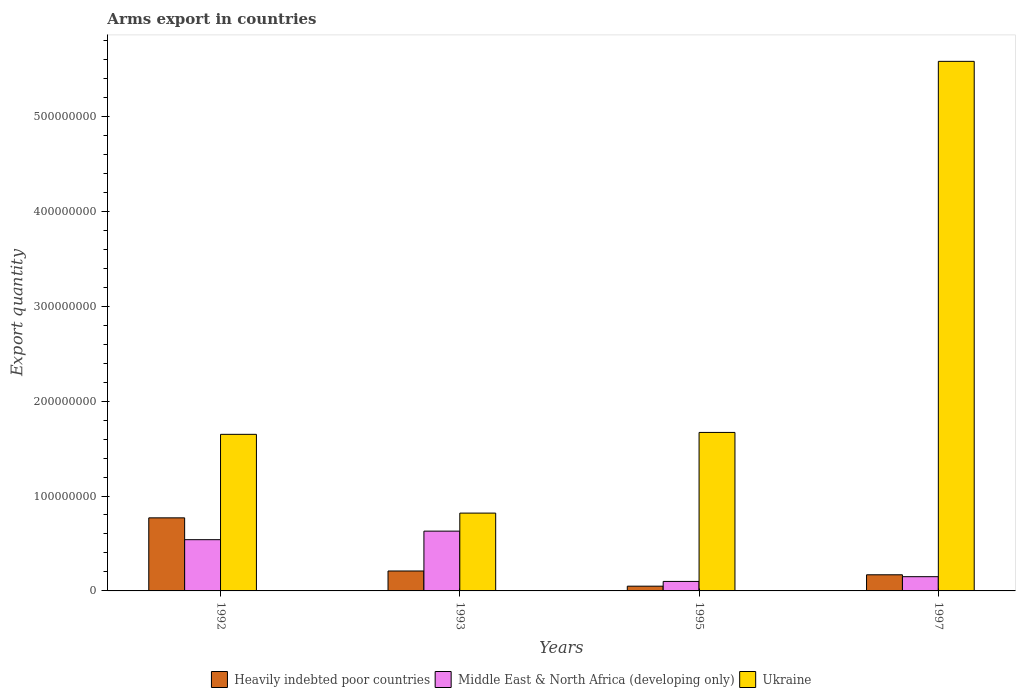How many different coloured bars are there?
Your response must be concise. 3. How many bars are there on the 4th tick from the left?
Provide a succinct answer. 3. How many bars are there on the 1st tick from the right?
Your answer should be compact. 3. In how many cases, is the number of bars for a given year not equal to the number of legend labels?
Give a very brief answer. 0. What is the total arms export in Middle East & North Africa (developing only) in 1997?
Your answer should be compact. 1.50e+07. Across all years, what is the maximum total arms export in Ukraine?
Your answer should be compact. 5.58e+08. What is the total total arms export in Heavily indebted poor countries in the graph?
Make the answer very short. 1.20e+08. What is the difference between the total arms export in Ukraine in 1993 and that in 1997?
Give a very brief answer. -4.76e+08. What is the average total arms export in Middle East & North Africa (developing only) per year?
Your response must be concise. 3.55e+07. In the year 1995, what is the difference between the total arms export in Ukraine and total arms export in Middle East & North Africa (developing only)?
Give a very brief answer. 1.57e+08. In how many years, is the total arms export in Middle East & North Africa (developing only) greater than 300000000?
Offer a terse response. 0. Is the difference between the total arms export in Ukraine in 1993 and 1997 greater than the difference between the total arms export in Middle East & North Africa (developing only) in 1993 and 1997?
Provide a short and direct response. No. What is the difference between the highest and the second highest total arms export in Middle East & North Africa (developing only)?
Your response must be concise. 9.00e+06. What is the difference between the highest and the lowest total arms export in Ukraine?
Offer a very short reply. 4.76e+08. In how many years, is the total arms export in Heavily indebted poor countries greater than the average total arms export in Heavily indebted poor countries taken over all years?
Your answer should be compact. 1. What does the 2nd bar from the left in 1992 represents?
Your answer should be compact. Middle East & North Africa (developing only). What does the 1st bar from the right in 1997 represents?
Your response must be concise. Ukraine. How many bars are there?
Give a very brief answer. 12. Are all the bars in the graph horizontal?
Your response must be concise. No. Are the values on the major ticks of Y-axis written in scientific E-notation?
Keep it short and to the point. No. How many legend labels are there?
Offer a terse response. 3. What is the title of the graph?
Your response must be concise. Arms export in countries. What is the label or title of the Y-axis?
Provide a short and direct response. Export quantity. What is the Export quantity of Heavily indebted poor countries in 1992?
Give a very brief answer. 7.70e+07. What is the Export quantity of Middle East & North Africa (developing only) in 1992?
Offer a very short reply. 5.40e+07. What is the Export quantity in Ukraine in 1992?
Make the answer very short. 1.65e+08. What is the Export quantity in Heavily indebted poor countries in 1993?
Keep it short and to the point. 2.10e+07. What is the Export quantity of Middle East & North Africa (developing only) in 1993?
Your response must be concise. 6.30e+07. What is the Export quantity in Ukraine in 1993?
Give a very brief answer. 8.20e+07. What is the Export quantity in Heavily indebted poor countries in 1995?
Ensure brevity in your answer.  5.00e+06. What is the Export quantity in Middle East & North Africa (developing only) in 1995?
Your answer should be compact. 1.00e+07. What is the Export quantity in Ukraine in 1995?
Give a very brief answer. 1.67e+08. What is the Export quantity of Heavily indebted poor countries in 1997?
Offer a very short reply. 1.70e+07. What is the Export quantity of Middle East & North Africa (developing only) in 1997?
Ensure brevity in your answer.  1.50e+07. What is the Export quantity in Ukraine in 1997?
Your response must be concise. 5.58e+08. Across all years, what is the maximum Export quantity of Heavily indebted poor countries?
Your response must be concise. 7.70e+07. Across all years, what is the maximum Export quantity in Middle East & North Africa (developing only)?
Provide a short and direct response. 6.30e+07. Across all years, what is the maximum Export quantity in Ukraine?
Your answer should be very brief. 5.58e+08. Across all years, what is the minimum Export quantity in Heavily indebted poor countries?
Your response must be concise. 5.00e+06. Across all years, what is the minimum Export quantity in Middle East & North Africa (developing only)?
Your answer should be compact. 1.00e+07. Across all years, what is the minimum Export quantity in Ukraine?
Your response must be concise. 8.20e+07. What is the total Export quantity of Heavily indebted poor countries in the graph?
Your response must be concise. 1.20e+08. What is the total Export quantity of Middle East & North Africa (developing only) in the graph?
Your answer should be very brief. 1.42e+08. What is the total Export quantity in Ukraine in the graph?
Keep it short and to the point. 9.72e+08. What is the difference between the Export quantity of Heavily indebted poor countries in 1992 and that in 1993?
Your answer should be compact. 5.60e+07. What is the difference between the Export quantity in Middle East & North Africa (developing only) in 1992 and that in 1993?
Offer a terse response. -9.00e+06. What is the difference between the Export quantity of Ukraine in 1992 and that in 1993?
Provide a succinct answer. 8.30e+07. What is the difference between the Export quantity in Heavily indebted poor countries in 1992 and that in 1995?
Ensure brevity in your answer.  7.20e+07. What is the difference between the Export quantity in Middle East & North Africa (developing only) in 1992 and that in 1995?
Provide a short and direct response. 4.40e+07. What is the difference between the Export quantity in Ukraine in 1992 and that in 1995?
Keep it short and to the point. -2.00e+06. What is the difference between the Export quantity in Heavily indebted poor countries in 1992 and that in 1997?
Give a very brief answer. 6.00e+07. What is the difference between the Export quantity of Middle East & North Africa (developing only) in 1992 and that in 1997?
Provide a succinct answer. 3.90e+07. What is the difference between the Export quantity in Ukraine in 1992 and that in 1997?
Give a very brief answer. -3.93e+08. What is the difference between the Export quantity of Heavily indebted poor countries in 1993 and that in 1995?
Your answer should be very brief. 1.60e+07. What is the difference between the Export quantity in Middle East & North Africa (developing only) in 1993 and that in 1995?
Ensure brevity in your answer.  5.30e+07. What is the difference between the Export quantity of Ukraine in 1993 and that in 1995?
Your answer should be compact. -8.50e+07. What is the difference between the Export quantity in Heavily indebted poor countries in 1993 and that in 1997?
Offer a very short reply. 4.00e+06. What is the difference between the Export quantity of Middle East & North Africa (developing only) in 1993 and that in 1997?
Offer a very short reply. 4.80e+07. What is the difference between the Export quantity of Ukraine in 1993 and that in 1997?
Your answer should be very brief. -4.76e+08. What is the difference between the Export quantity of Heavily indebted poor countries in 1995 and that in 1997?
Ensure brevity in your answer.  -1.20e+07. What is the difference between the Export quantity of Middle East & North Africa (developing only) in 1995 and that in 1997?
Keep it short and to the point. -5.00e+06. What is the difference between the Export quantity of Ukraine in 1995 and that in 1997?
Provide a succinct answer. -3.91e+08. What is the difference between the Export quantity of Heavily indebted poor countries in 1992 and the Export quantity of Middle East & North Africa (developing only) in 1993?
Provide a short and direct response. 1.40e+07. What is the difference between the Export quantity in Heavily indebted poor countries in 1992 and the Export quantity in Ukraine in 1993?
Provide a short and direct response. -5.00e+06. What is the difference between the Export quantity of Middle East & North Africa (developing only) in 1992 and the Export quantity of Ukraine in 1993?
Offer a very short reply. -2.80e+07. What is the difference between the Export quantity of Heavily indebted poor countries in 1992 and the Export quantity of Middle East & North Africa (developing only) in 1995?
Offer a terse response. 6.70e+07. What is the difference between the Export quantity of Heavily indebted poor countries in 1992 and the Export quantity of Ukraine in 1995?
Keep it short and to the point. -9.00e+07. What is the difference between the Export quantity in Middle East & North Africa (developing only) in 1992 and the Export quantity in Ukraine in 1995?
Give a very brief answer. -1.13e+08. What is the difference between the Export quantity in Heavily indebted poor countries in 1992 and the Export quantity in Middle East & North Africa (developing only) in 1997?
Ensure brevity in your answer.  6.20e+07. What is the difference between the Export quantity of Heavily indebted poor countries in 1992 and the Export quantity of Ukraine in 1997?
Make the answer very short. -4.81e+08. What is the difference between the Export quantity in Middle East & North Africa (developing only) in 1992 and the Export quantity in Ukraine in 1997?
Your answer should be compact. -5.04e+08. What is the difference between the Export quantity of Heavily indebted poor countries in 1993 and the Export quantity of Middle East & North Africa (developing only) in 1995?
Give a very brief answer. 1.10e+07. What is the difference between the Export quantity of Heavily indebted poor countries in 1993 and the Export quantity of Ukraine in 1995?
Your answer should be compact. -1.46e+08. What is the difference between the Export quantity in Middle East & North Africa (developing only) in 1993 and the Export quantity in Ukraine in 1995?
Ensure brevity in your answer.  -1.04e+08. What is the difference between the Export quantity in Heavily indebted poor countries in 1993 and the Export quantity in Ukraine in 1997?
Ensure brevity in your answer.  -5.37e+08. What is the difference between the Export quantity of Middle East & North Africa (developing only) in 1993 and the Export quantity of Ukraine in 1997?
Give a very brief answer. -4.95e+08. What is the difference between the Export quantity in Heavily indebted poor countries in 1995 and the Export quantity in Middle East & North Africa (developing only) in 1997?
Your answer should be very brief. -1.00e+07. What is the difference between the Export quantity of Heavily indebted poor countries in 1995 and the Export quantity of Ukraine in 1997?
Your answer should be compact. -5.53e+08. What is the difference between the Export quantity of Middle East & North Africa (developing only) in 1995 and the Export quantity of Ukraine in 1997?
Your response must be concise. -5.48e+08. What is the average Export quantity in Heavily indebted poor countries per year?
Give a very brief answer. 3.00e+07. What is the average Export quantity of Middle East & North Africa (developing only) per year?
Your answer should be very brief. 3.55e+07. What is the average Export quantity in Ukraine per year?
Your answer should be very brief. 2.43e+08. In the year 1992, what is the difference between the Export quantity in Heavily indebted poor countries and Export quantity in Middle East & North Africa (developing only)?
Provide a succinct answer. 2.30e+07. In the year 1992, what is the difference between the Export quantity of Heavily indebted poor countries and Export quantity of Ukraine?
Give a very brief answer. -8.80e+07. In the year 1992, what is the difference between the Export quantity in Middle East & North Africa (developing only) and Export quantity in Ukraine?
Make the answer very short. -1.11e+08. In the year 1993, what is the difference between the Export quantity of Heavily indebted poor countries and Export quantity of Middle East & North Africa (developing only)?
Offer a very short reply. -4.20e+07. In the year 1993, what is the difference between the Export quantity in Heavily indebted poor countries and Export quantity in Ukraine?
Ensure brevity in your answer.  -6.10e+07. In the year 1993, what is the difference between the Export quantity in Middle East & North Africa (developing only) and Export quantity in Ukraine?
Offer a terse response. -1.90e+07. In the year 1995, what is the difference between the Export quantity of Heavily indebted poor countries and Export quantity of Middle East & North Africa (developing only)?
Your response must be concise. -5.00e+06. In the year 1995, what is the difference between the Export quantity of Heavily indebted poor countries and Export quantity of Ukraine?
Offer a terse response. -1.62e+08. In the year 1995, what is the difference between the Export quantity in Middle East & North Africa (developing only) and Export quantity in Ukraine?
Provide a short and direct response. -1.57e+08. In the year 1997, what is the difference between the Export quantity in Heavily indebted poor countries and Export quantity in Middle East & North Africa (developing only)?
Make the answer very short. 2.00e+06. In the year 1997, what is the difference between the Export quantity in Heavily indebted poor countries and Export quantity in Ukraine?
Ensure brevity in your answer.  -5.41e+08. In the year 1997, what is the difference between the Export quantity of Middle East & North Africa (developing only) and Export quantity of Ukraine?
Your answer should be compact. -5.43e+08. What is the ratio of the Export quantity in Heavily indebted poor countries in 1992 to that in 1993?
Ensure brevity in your answer.  3.67. What is the ratio of the Export quantity of Middle East & North Africa (developing only) in 1992 to that in 1993?
Provide a succinct answer. 0.86. What is the ratio of the Export quantity in Ukraine in 1992 to that in 1993?
Provide a succinct answer. 2.01. What is the ratio of the Export quantity of Middle East & North Africa (developing only) in 1992 to that in 1995?
Offer a very short reply. 5.4. What is the ratio of the Export quantity in Heavily indebted poor countries in 1992 to that in 1997?
Provide a succinct answer. 4.53. What is the ratio of the Export quantity in Ukraine in 1992 to that in 1997?
Offer a terse response. 0.3. What is the ratio of the Export quantity in Heavily indebted poor countries in 1993 to that in 1995?
Your answer should be compact. 4.2. What is the ratio of the Export quantity of Ukraine in 1993 to that in 1995?
Provide a short and direct response. 0.49. What is the ratio of the Export quantity of Heavily indebted poor countries in 1993 to that in 1997?
Offer a very short reply. 1.24. What is the ratio of the Export quantity of Ukraine in 1993 to that in 1997?
Your answer should be compact. 0.15. What is the ratio of the Export quantity of Heavily indebted poor countries in 1995 to that in 1997?
Provide a succinct answer. 0.29. What is the ratio of the Export quantity in Ukraine in 1995 to that in 1997?
Your answer should be very brief. 0.3. What is the difference between the highest and the second highest Export quantity in Heavily indebted poor countries?
Offer a terse response. 5.60e+07. What is the difference between the highest and the second highest Export quantity in Middle East & North Africa (developing only)?
Give a very brief answer. 9.00e+06. What is the difference between the highest and the second highest Export quantity of Ukraine?
Give a very brief answer. 3.91e+08. What is the difference between the highest and the lowest Export quantity of Heavily indebted poor countries?
Keep it short and to the point. 7.20e+07. What is the difference between the highest and the lowest Export quantity in Middle East & North Africa (developing only)?
Keep it short and to the point. 5.30e+07. What is the difference between the highest and the lowest Export quantity in Ukraine?
Keep it short and to the point. 4.76e+08. 